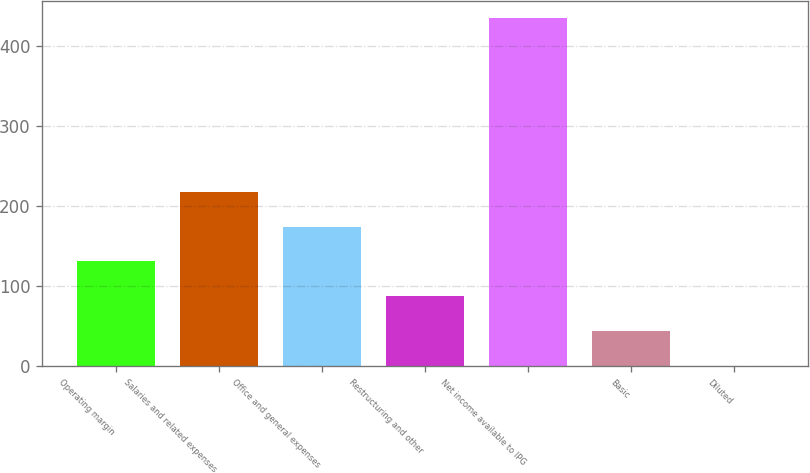Convert chart to OTSL. <chart><loc_0><loc_0><loc_500><loc_500><bar_chart><fcel>Operating margin<fcel>Salaries and related expenses<fcel>Office and general expenses<fcel>Restructuring and other<fcel>Net income available to IPG<fcel>Basic<fcel>Diluted<nl><fcel>131.2<fcel>218.04<fcel>174.62<fcel>87.78<fcel>435.1<fcel>44.36<fcel>0.94<nl></chart> 